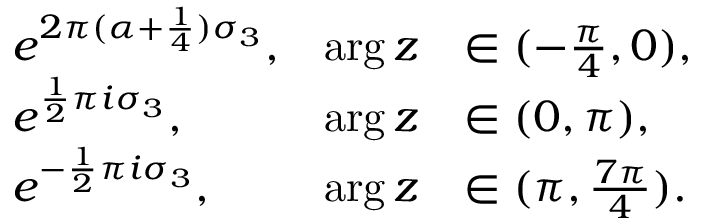<formula> <loc_0><loc_0><loc_500><loc_500>\begin{array} { r l r l } & { e ^ { 2 \pi ( \alpha + \frac { 1 } { 4 } ) \sigma _ { 3 } } , } & { \arg z } & { \in ( - \frac { \pi } { 4 } , 0 ) , } \\ & { e ^ { \frac { 1 } { 2 } \pi i \sigma _ { 3 } } , } & { \arg z } & { \in ( 0 , \pi ) , } \\ & { e ^ { - \frac { 1 } { 2 } \pi i \sigma _ { 3 } } , } & { \arg z } & { \in ( \pi , \frac { 7 \pi } { 4 } ) . } \end{array}</formula> 